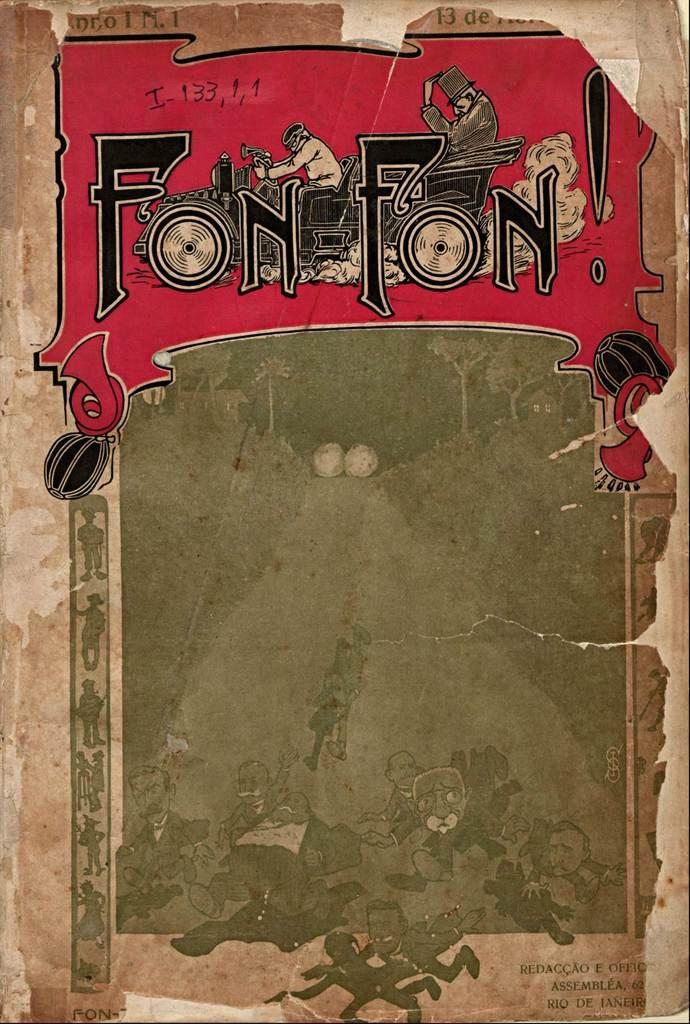Provide a one-sentence caption for the provided image. A very old looking book which has the words Fon Fon across the top. 